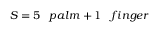Convert formula to latex. <formula><loc_0><loc_0><loc_500><loc_500>S = 5 \, p a l m + 1 \, f i n g e r</formula> 